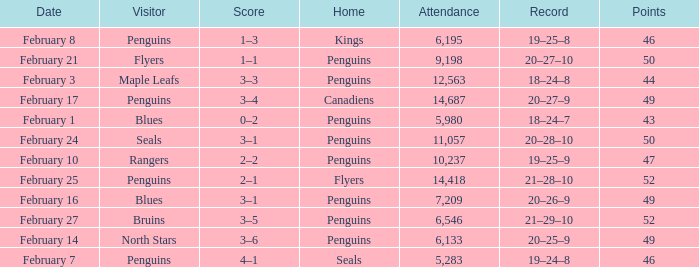Write the full table. {'header': ['Date', 'Visitor', 'Score', 'Home', 'Attendance', 'Record', 'Points'], 'rows': [['February 8', 'Penguins', '1–3', 'Kings', '6,195', '19–25–8', '46'], ['February 21', 'Flyers', '1–1', 'Penguins', '9,198', '20–27–10', '50'], ['February 3', 'Maple Leafs', '3–3', 'Penguins', '12,563', '18–24–8', '44'], ['February 17', 'Penguins', '3–4', 'Canadiens', '14,687', '20–27–9', '49'], ['February 1', 'Blues', '0–2', 'Penguins', '5,980', '18–24–7', '43'], ['February 24', 'Seals', '3–1', 'Penguins', '11,057', '20–28–10', '50'], ['February 10', 'Rangers', '2–2', 'Penguins', '10,237', '19–25–9', '47'], ['February 25', 'Penguins', '2–1', 'Flyers', '14,418', '21–28–10', '52'], ['February 16', 'Blues', '3–1', 'Penguins', '7,209', '20–26–9', '49'], ['February 27', 'Bruins', '3–5', 'Penguins', '6,546', '21–29–10', '52'], ['February 14', 'North Stars', '3–6', 'Penguins', '6,133', '20–25–9', '49'], ['February 7', 'Penguins', '4–1', 'Seals', '5,283', '19–24–8', '46']]} Home of kings had what score? 1–3. 